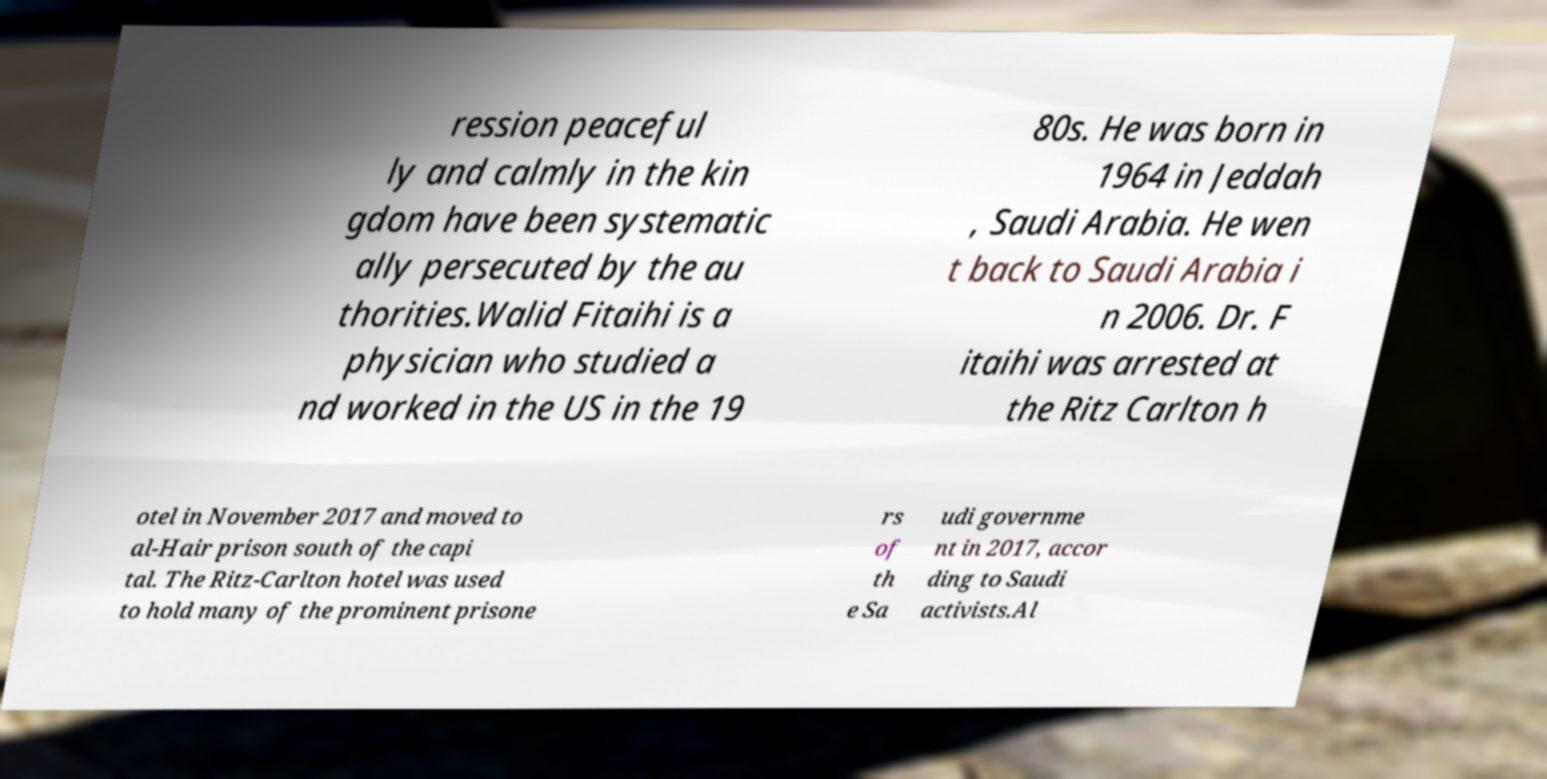What messages or text are displayed in this image? I need them in a readable, typed format. ression peaceful ly and calmly in the kin gdom have been systematic ally persecuted by the au thorities.Walid Fitaihi is a physician who studied a nd worked in the US in the 19 80s. He was born in 1964 in Jeddah , Saudi Arabia. He wen t back to Saudi Arabia i n 2006. Dr. F itaihi was arrested at the Ritz Carlton h otel in November 2017 and moved to al-Hair prison south of the capi tal. The Ritz-Carlton hotel was used to hold many of the prominent prisone rs of th e Sa udi governme nt in 2017, accor ding to Saudi activists.Al 